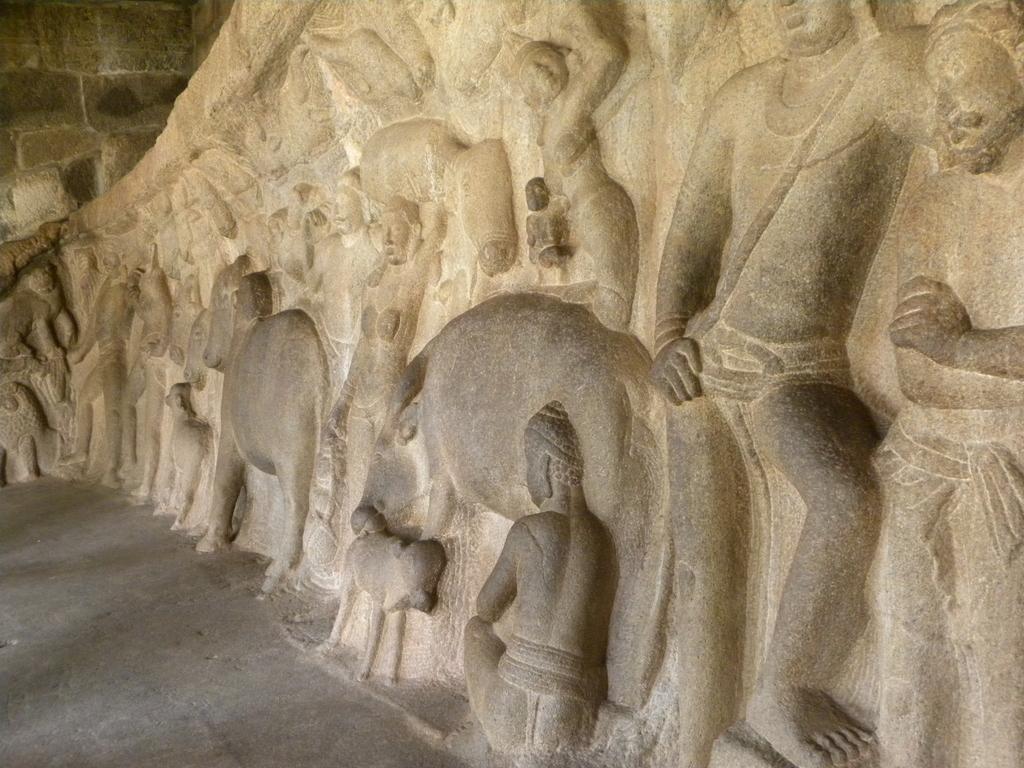Please provide a concise description of this image. In this image there is a wall on which there are sculptures of persons and animals. 